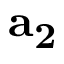<formula> <loc_0><loc_0><loc_500><loc_500>a _ { 2 }</formula> 